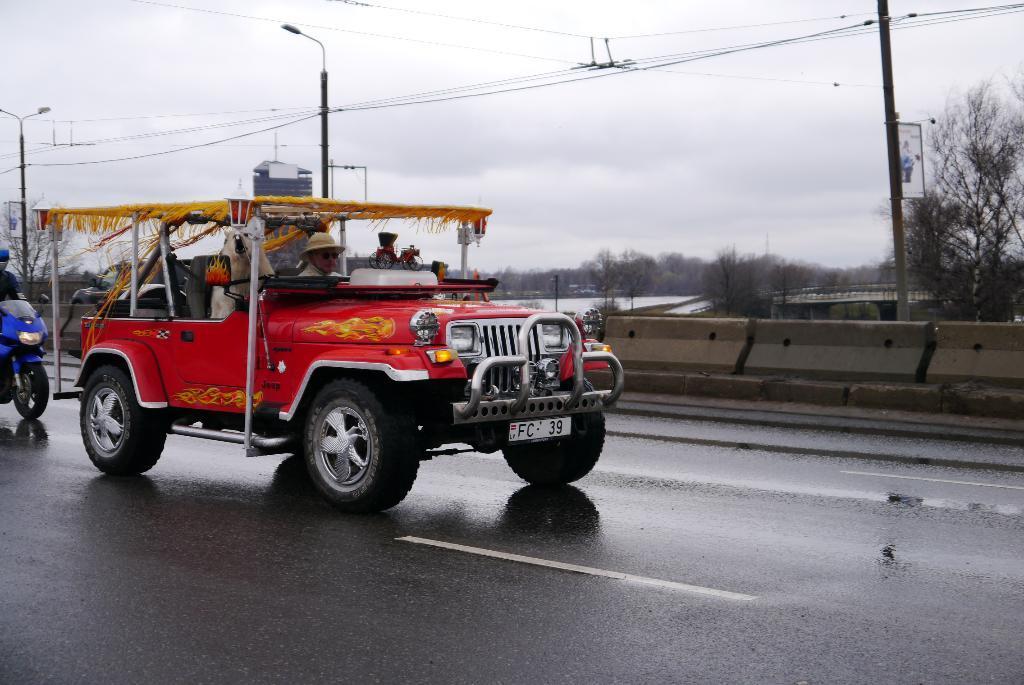In one or two sentences, can you explain what this image depicts? In this image there is a vehicle. A person wearing a hat is sitting in the vehicle. Beside him there is an animal. Left side there is a person riding a bike on the road. Right side there are roadblocks. Behind there are street lights connected with wires. Background there are trees and houses. Top of the image there is sky. 